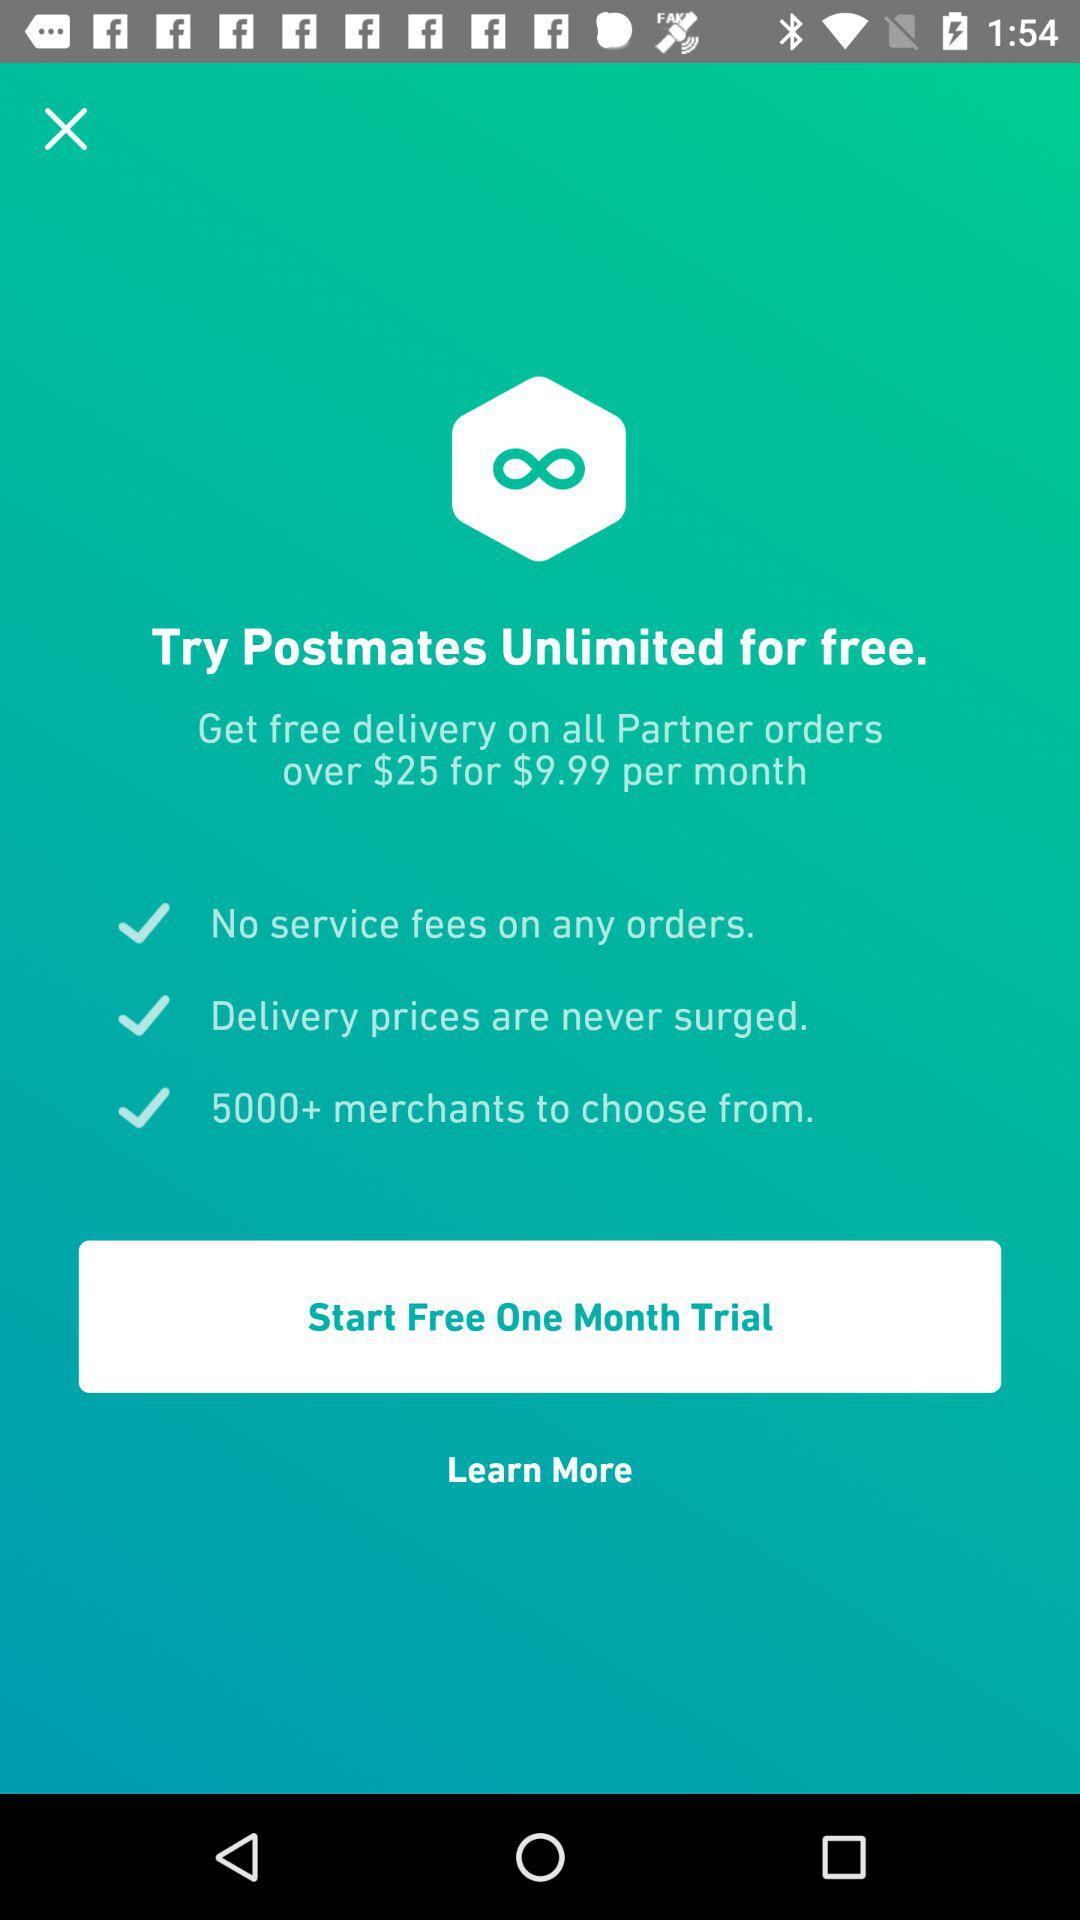How many merchants choose Postmates?
When the provided information is insufficient, respond with <no answer>. <no answer> 